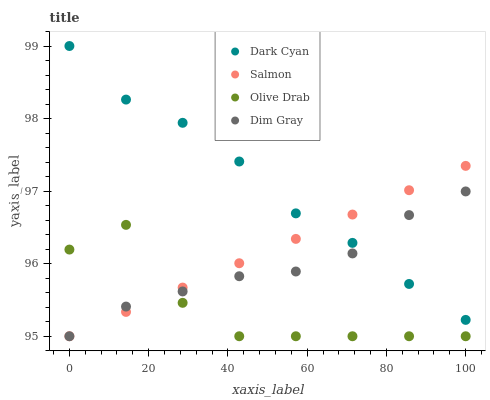Does Olive Drab have the minimum area under the curve?
Answer yes or no. Yes. Does Dark Cyan have the maximum area under the curve?
Answer yes or no. Yes. Does Dim Gray have the minimum area under the curve?
Answer yes or no. No. Does Dim Gray have the maximum area under the curve?
Answer yes or no. No. Is Salmon the smoothest?
Answer yes or no. Yes. Is Olive Drab the roughest?
Answer yes or no. Yes. Is Dim Gray the smoothest?
Answer yes or no. No. Is Dim Gray the roughest?
Answer yes or no. No. Does Dim Gray have the lowest value?
Answer yes or no. Yes. Does Dark Cyan have the highest value?
Answer yes or no. Yes. Does Dim Gray have the highest value?
Answer yes or no. No. Is Olive Drab less than Dark Cyan?
Answer yes or no. Yes. Is Dark Cyan greater than Olive Drab?
Answer yes or no. Yes. Does Dim Gray intersect Salmon?
Answer yes or no. Yes. Is Dim Gray less than Salmon?
Answer yes or no. No. Is Dim Gray greater than Salmon?
Answer yes or no. No. Does Olive Drab intersect Dark Cyan?
Answer yes or no. No. 